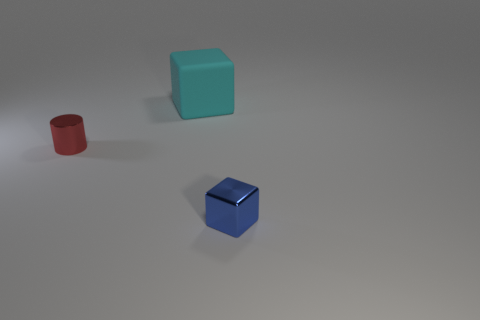Is there any other thing that has the same material as the large cyan cube?
Offer a terse response. No. Are there any other things that have the same shape as the small red object?
Ensure brevity in your answer.  No. What is the shape of the tiny metal thing behind the tiny object on the right side of the tiny shiny object that is on the left side of the large cyan cube?
Make the answer very short. Cylinder. What size is the block that is the same material as the small red cylinder?
Provide a succinct answer. Small. Is the number of small blue metallic things greater than the number of blue metallic spheres?
Your response must be concise. Yes. There is another thing that is the same size as the red metallic thing; what is its material?
Ensure brevity in your answer.  Metal. Is the size of the metal thing that is behind the blue shiny thing the same as the tiny blue metal block?
Provide a succinct answer. Yes. What number of spheres are either small red objects or cyan things?
Keep it short and to the point. 0. There is a small thing that is on the left side of the blue metallic object; what material is it?
Your answer should be compact. Metal. Is the number of red things less than the number of small metal objects?
Ensure brevity in your answer.  Yes. 